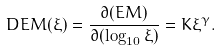Convert formula to latex. <formula><loc_0><loc_0><loc_500><loc_500>D E M ( \xi ) = \frac { \partial ( E M ) } { \partial ( \log _ { 1 0 } \xi ) } = K \xi ^ { \gamma } .</formula> 